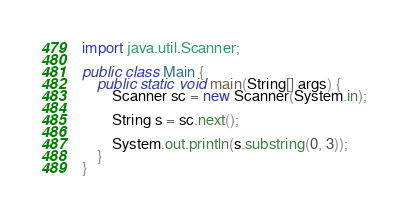<code> <loc_0><loc_0><loc_500><loc_500><_Java_>import java.util.Scanner;
        
public class Main {
    public static void main(String[] args) {
        Scanner sc = new Scanner(System.in);
        
        String s = sc.next();
        
        System.out.println(s.substring(0, 3));
    }
}</code> 